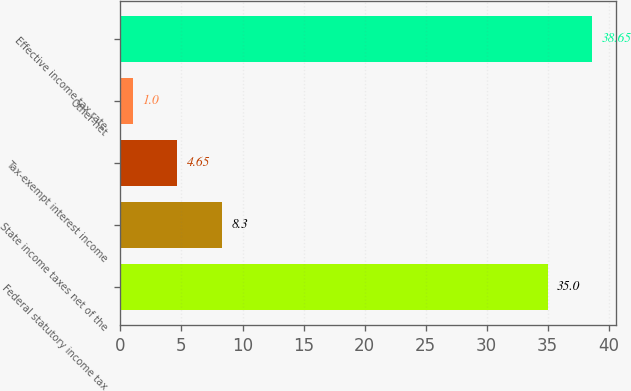<chart> <loc_0><loc_0><loc_500><loc_500><bar_chart><fcel>Federal statutory income tax<fcel>State income taxes net of the<fcel>Tax-exempt interest income<fcel>Other-net<fcel>Effective income tax rate<nl><fcel>35<fcel>8.3<fcel>4.65<fcel>1<fcel>38.65<nl></chart> 